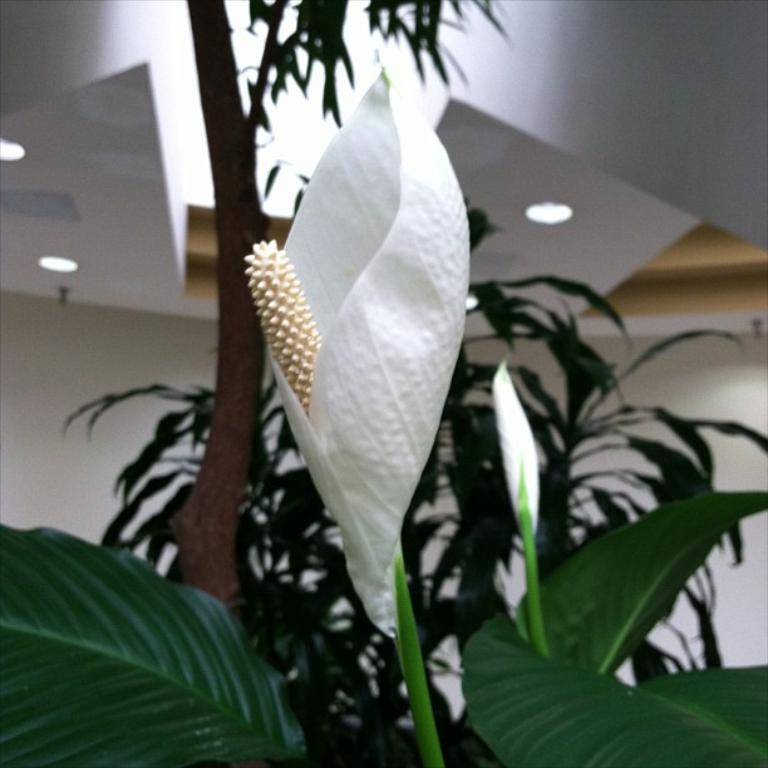What celestial bodies are depicted in the image? There are planets in the image. What type of plant is present in the image? There is a flower in the image. What is the color of the flower? The flower is white in color. What type of patch is sewn onto the father's shirt in the image? There is no father or shirt present in the image; it features planets and a white flower. 